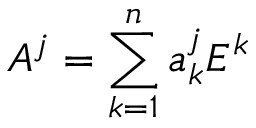<formula> <loc_0><loc_0><loc_500><loc_500>A ^ { j } = \sum _ { k = 1 } ^ { n } a _ { k } ^ { j } E ^ { k }</formula> 